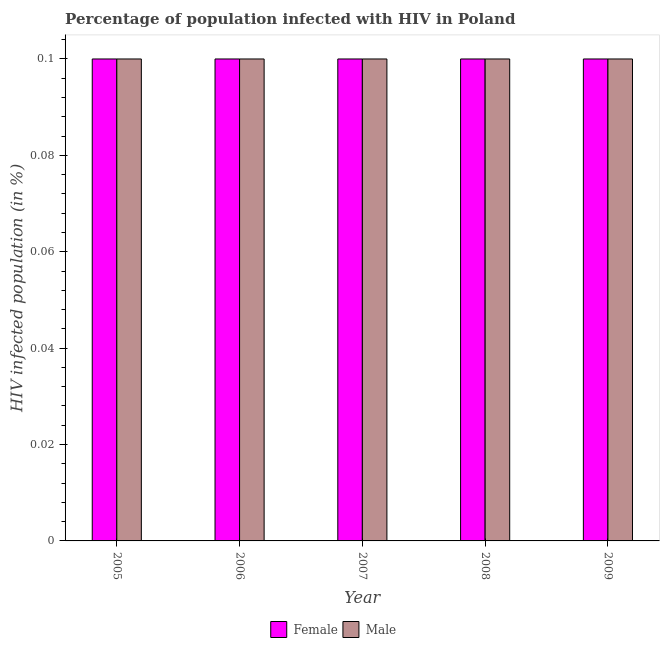How many bars are there on the 1st tick from the right?
Offer a terse response. 2. What is the percentage of females who are infected with hiv in 2008?
Offer a terse response. 0.1. Across all years, what is the maximum percentage of males who are infected with hiv?
Your response must be concise. 0.1. What is the difference between the percentage of males who are infected with hiv in 2006 and the percentage of females who are infected with hiv in 2008?
Your answer should be very brief. 0. What is the average percentage of males who are infected with hiv per year?
Keep it short and to the point. 0.1. In the year 2007, what is the difference between the percentage of females who are infected with hiv and percentage of males who are infected with hiv?
Ensure brevity in your answer.  0. Is the percentage of females who are infected with hiv in 2005 less than that in 2007?
Your answer should be compact. No. Is the sum of the percentage of males who are infected with hiv in 2005 and 2007 greater than the maximum percentage of females who are infected with hiv across all years?
Make the answer very short. Yes. What does the 1st bar from the left in 2008 represents?
Give a very brief answer. Female. What does the 1st bar from the right in 2008 represents?
Your answer should be compact. Male. How many bars are there?
Your answer should be very brief. 10. How many years are there in the graph?
Keep it short and to the point. 5. Are the values on the major ticks of Y-axis written in scientific E-notation?
Ensure brevity in your answer.  No. How many legend labels are there?
Your answer should be very brief. 2. What is the title of the graph?
Your answer should be compact. Percentage of population infected with HIV in Poland. What is the label or title of the Y-axis?
Ensure brevity in your answer.  HIV infected population (in %). What is the HIV infected population (in %) in Female in 2008?
Your answer should be very brief. 0.1. What is the HIV infected population (in %) in Female in 2009?
Keep it short and to the point. 0.1. Across all years, what is the minimum HIV infected population (in %) in Female?
Your answer should be very brief. 0.1. Across all years, what is the minimum HIV infected population (in %) of Male?
Ensure brevity in your answer.  0.1. What is the total HIV infected population (in %) of Female in the graph?
Offer a terse response. 0.5. What is the total HIV infected population (in %) in Male in the graph?
Your answer should be very brief. 0.5. What is the difference between the HIV infected population (in %) in Female in 2005 and that in 2006?
Give a very brief answer. 0. What is the difference between the HIV infected population (in %) of Male in 2005 and that in 2006?
Keep it short and to the point. 0. What is the difference between the HIV infected population (in %) in Female in 2005 and that in 2007?
Keep it short and to the point. 0. What is the difference between the HIV infected population (in %) of Male in 2005 and that in 2007?
Offer a very short reply. 0. What is the difference between the HIV infected population (in %) in Female in 2005 and that in 2008?
Make the answer very short. 0. What is the difference between the HIV infected population (in %) of Male in 2005 and that in 2009?
Offer a very short reply. 0. What is the difference between the HIV infected population (in %) in Male in 2006 and that in 2007?
Offer a very short reply. 0. What is the difference between the HIV infected population (in %) in Male in 2006 and that in 2008?
Provide a succinct answer. 0. What is the difference between the HIV infected population (in %) of Female in 2006 and that in 2009?
Ensure brevity in your answer.  0. What is the difference between the HIV infected population (in %) in Male in 2006 and that in 2009?
Your answer should be compact. 0. What is the difference between the HIV infected population (in %) of Female in 2007 and that in 2008?
Offer a terse response. 0. What is the difference between the HIV infected population (in %) of Male in 2007 and that in 2008?
Your response must be concise. 0. What is the difference between the HIV infected population (in %) of Female in 2007 and that in 2009?
Your answer should be very brief. 0. What is the difference between the HIV infected population (in %) of Male in 2007 and that in 2009?
Give a very brief answer. 0. What is the difference between the HIV infected population (in %) of Female in 2008 and that in 2009?
Provide a succinct answer. 0. What is the difference between the HIV infected population (in %) of Male in 2008 and that in 2009?
Provide a succinct answer. 0. What is the difference between the HIV infected population (in %) of Female in 2005 and the HIV infected population (in %) of Male in 2006?
Provide a short and direct response. 0. What is the difference between the HIV infected population (in %) in Female in 2006 and the HIV infected population (in %) in Male in 2008?
Your answer should be compact. 0. What is the difference between the HIV infected population (in %) in Female in 2007 and the HIV infected population (in %) in Male in 2009?
Keep it short and to the point. 0. What is the difference between the HIV infected population (in %) of Female in 2008 and the HIV infected population (in %) of Male in 2009?
Offer a terse response. 0. What is the average HIV infected population (in %) of Male per year?
Your response must be concise. 0.1. In the year 2007, what is the difference between the HIV infected population (in %) of Female and HIV infected population (in %) of Male?
Ensure brevity in your answer.  0. What is the ratio of the HIV infected population (in %) of Female in 2005 to that in 2006?
Keep it short and to the point. 1. What is the ratio of the HIV infected population (in %) in Male in 2005 to that in 2007?
Provide a short and direct response. 1. What is the ratio of the HIV infected population (in %) of Male in 2005 to that in 2008?
Ensure brevity in your answer.  1. What is the ratio of the HIV infected population (in %) of Female in 2005 to that in 2009?
Ensure brevity in your answer.  1. What is the ratio of the HIV infected population (in %) in Female in 2006 to that in 2009?
Your answer should be compact. 1. What is the ratio of the HIV infected population (in %) of Male in 2007 to that in 2008?
Offer a terse response. 1. What is the ratio of the HIV infected population (in %) in Female in 2007 to that in 2009?
Provide a short and direct response. 1. What is the ratio of the HIV infected population (in %) of Male in 2008 to that in 2009?
Offer a very short reply. 1. What is the difference between the highest and the second highest HIV infected population (in %) in Male?
Offer a terse response. 0. 